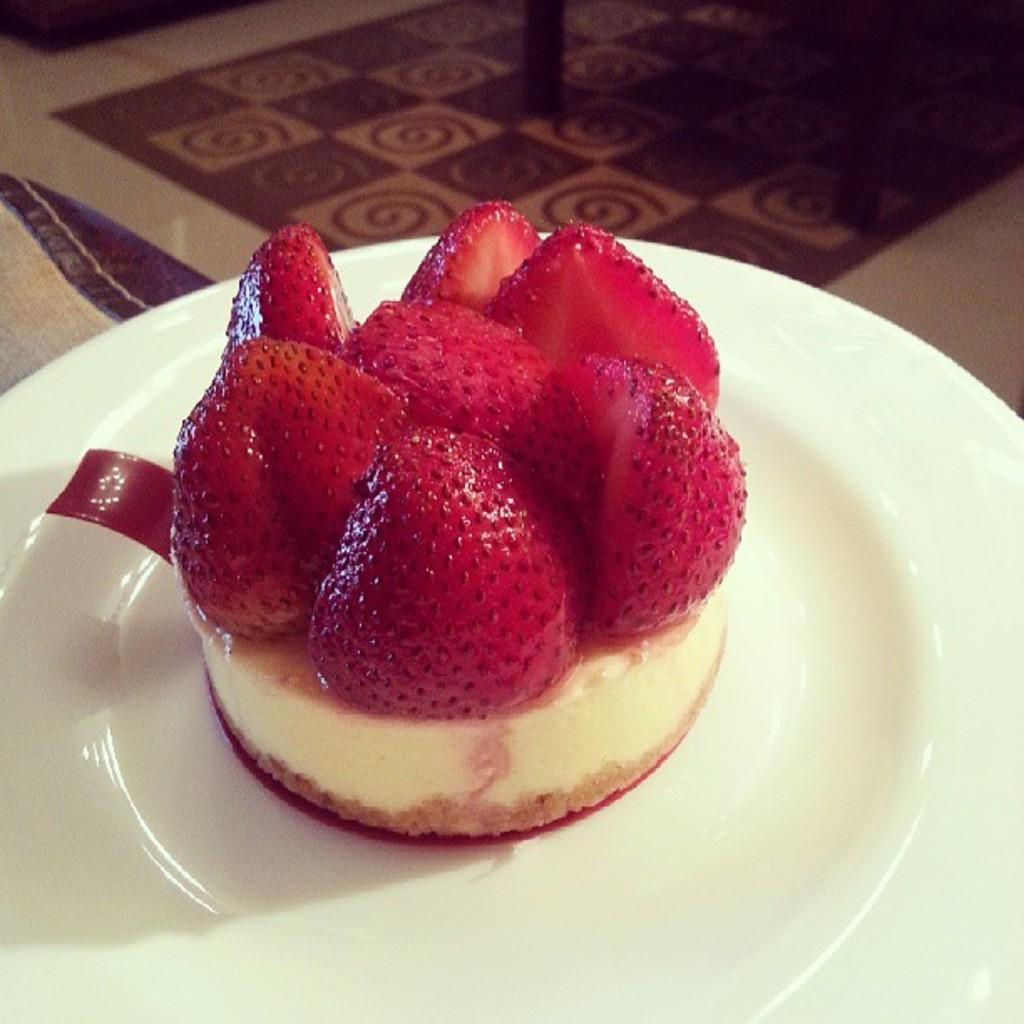In one or two sentences, can you explain what this image depicts? In this picture I can observe some food. There are some strawberries placed on the food. The food is placed in the plate. The plate is white color. 